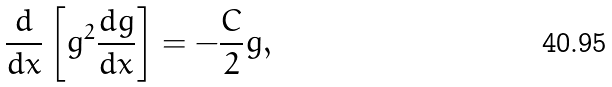<formula> <loc_0><loc_0><loc_500><loc_500>\frac { d } { d x } \left [ g ^ { 2 } \frac { d g } { d x } \right ] = - \frac { C } { 2 } g ,</formula> 